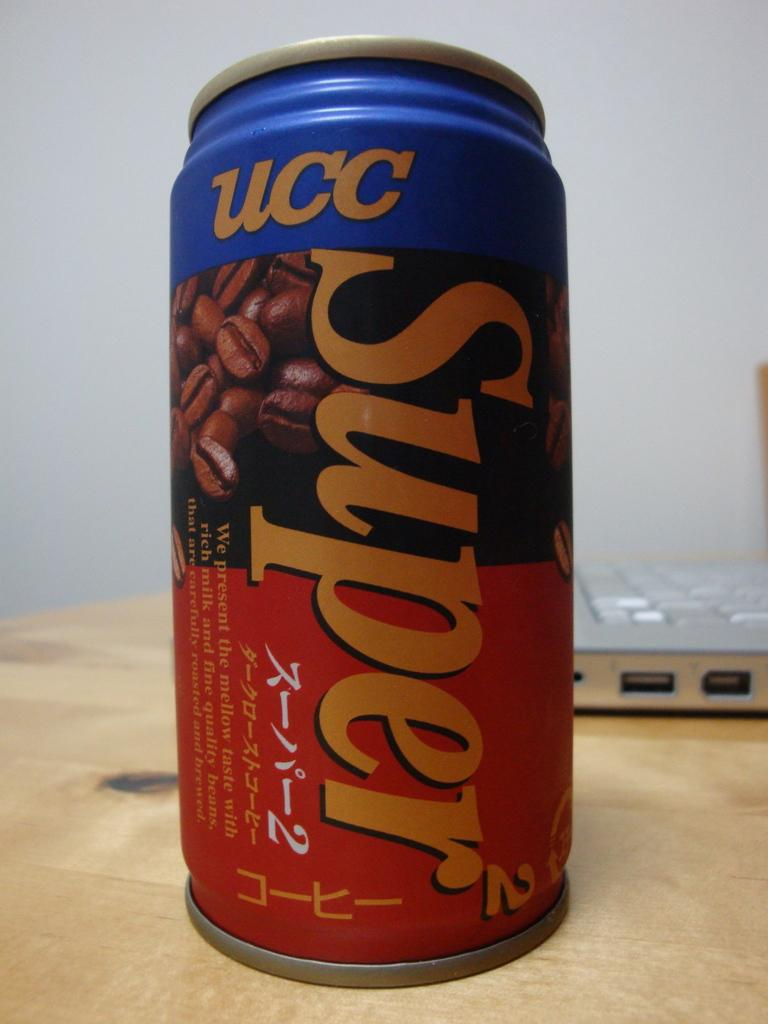<image>
Describe the image concisely. a can with the word super on on a table 